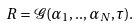<formula> <loc_0><loc_0><loc_500><loc_500>R = \mathcal { G } ( \alpha _ { 1 } , . . , \alpha _ { N } , \tau ) .</formula> 